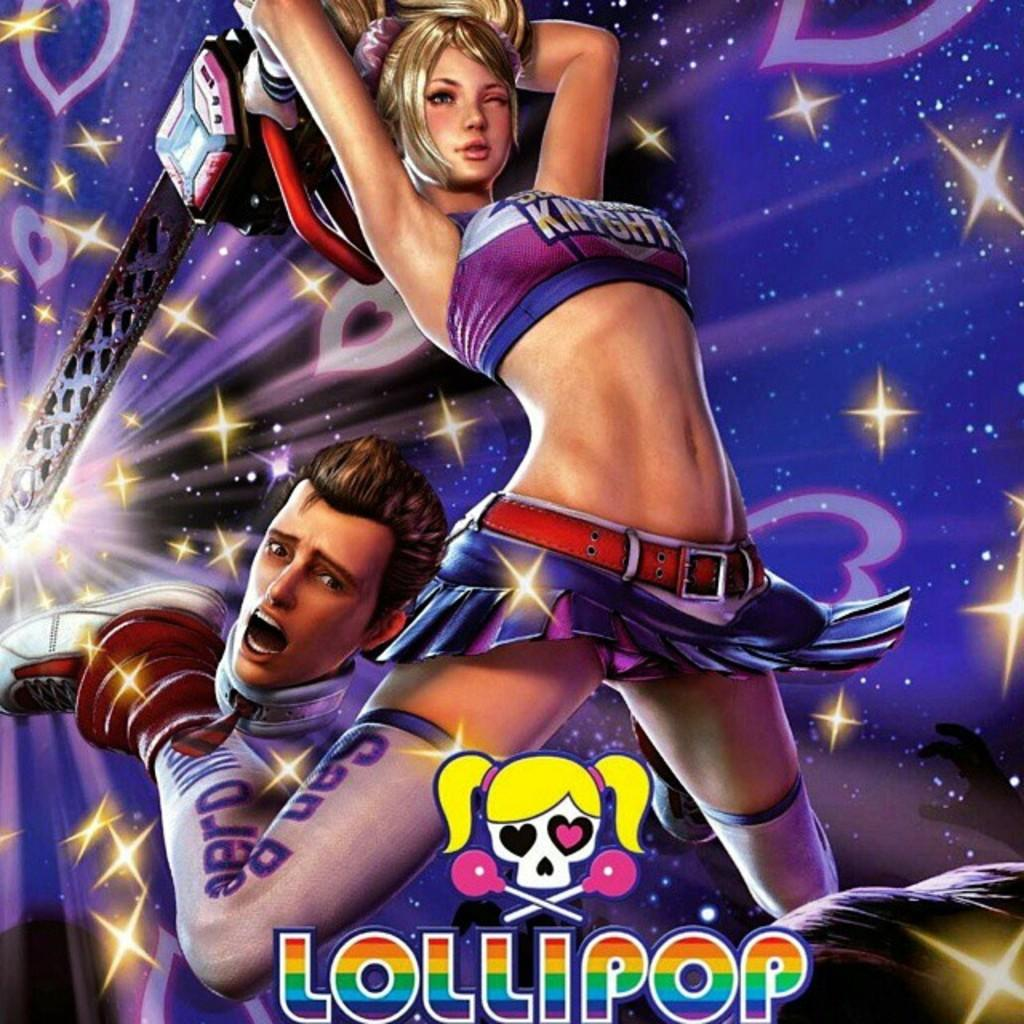<image>
Create a compact narrative representing the image presented. A poster shows a cartoon of a scantily clad girl with a chainsaw pushing a man out of her way  and the word Lollipop is at the bottom. 